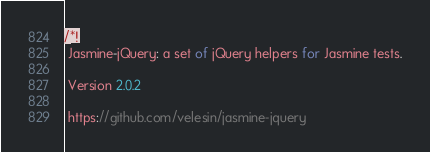<code> <loc_0><loc_0><loc_500><loc_500><_JavaScript_>/*!
 Jasmine-jQuery: a set of jQuery helpers for Jasmine tests.

 Version 2.0.2

 https://github.com/velesin/jasmine-jquery
</code> 